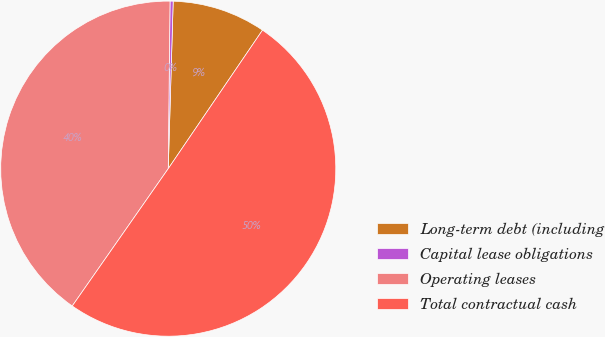<chart> <loc_0><loc_0><loc_500><loc_500><pie_chart><fcel>Long-term debt (including<fcel>Capital lease obligations<fcel>Operating leases<fcel>Total contractual cash<nl><fcel>9.04%<fcel>0.3%<fcel>40.46%<fcel>50.2%<nl></chart> 